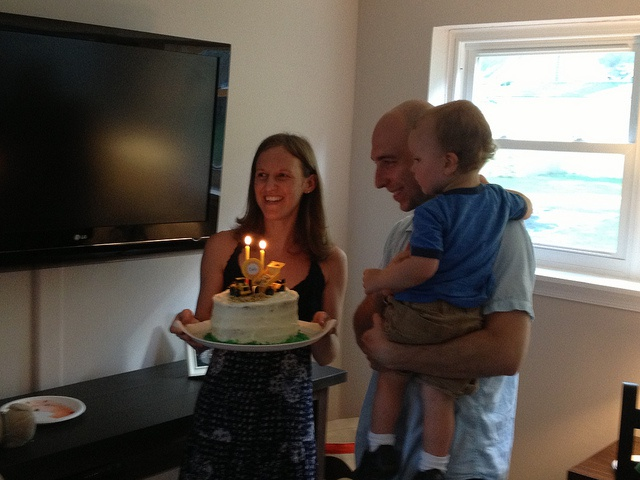Describe the objects in this image and their specific colors. I can see tv in gray and black tones, people in gray, black, and maroon tones, people in gray, black, maroon, and navy tones, people in gray, black, maroon, and darkgray tones, and dining table in gray, black, and purple tones in this image. 